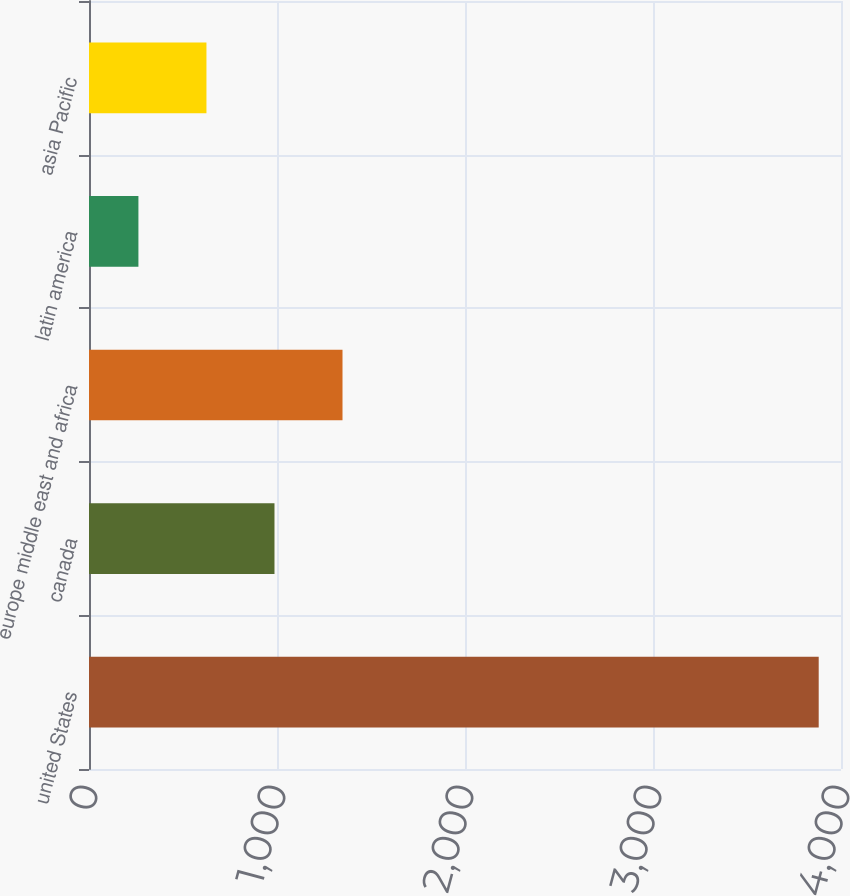Convert chart. <chart><loc_0><loc_0><loc_500><loc_500><bar_chart><fcel>united States<fcel>canada<fcel>europe middle east and africa<fcel>latin america<fcel>asia Pacific<nl><fcel>3881.4<fcel>986.6<fcel>1348.45<fcel>262.9<fcel>624.75<nl></chart> 